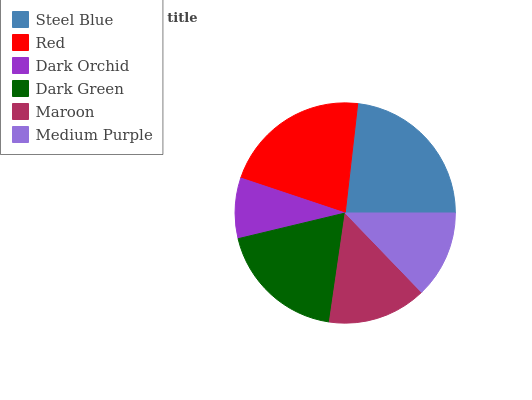Is Dark Orchid the minimum?
Answer yes or no. Yes. Is Steel Blue the maximum?
Answer yes or no. Yes. Is Red the minimum?
Answer yes or no. No. Is Red the maximum?
Answer yes or no. No. Is Steel Blue greater than Red?
Answer yes or no. Yes. Is Red less than Steel Blue?
Answer yes or no. Yes. Is Red greater than Steel Blue?
Answer yes or no. No. Is Steel Blue less than Red?
Answer yes or no. No. Is Dark Green the high median?
Answer yes or no. Yes. Is Maroon the low median?
Answer yes or no. Yes. Is Dark Orchid the high median?
Answer yes or no. No. Is Steel Blue the low median?
Answer yes or no. No. 